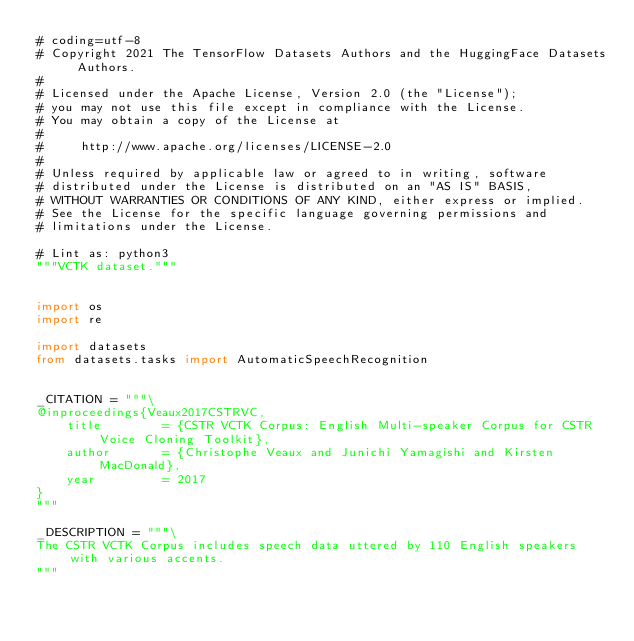<code> <loc_0><loc_0><loc_500><loc_500><_Python_># coding=utf-8
# Copyright 2021 The TensorFlow Datasets Authors and the HuggingFace Datasets Authors.
#
# Licensed under the Apache License, Version 2.0 (the "License");
# you may not use this file except in compliance with the License.
# You may obtain a copy of the License at
#
#     http://www.apache.org/licenses/LICENSE-2.0
#
# Unless required by applicable law or agreed to in writing, software
# distributed under the License is distributed on an "AS IS" BASIS,
# WITHOUT WARRANTIES OR CONDITIONS OF ANY KIND, either express or implied.
# See the License for the specific language governing permissions and
# limitations under the License.

# Lint as: python3
"""VCTK dataset."""


import os
import re

import datasets
from datasets.tasks import AutomaticSpeechRecognition


_CITATION = """\
@inproceedings{Veaux2017CSTRVC,
    title        = {CSTR VCTK Corpus: English Multi-speaker Corpus for CSTR Voice Cloning Toolkit},
    author       = {Christophe Veaux and Junichi Yamagishi and Kirsten MacDonald},
    year         = 2017
}
"""

_DESCRIPTION = """\
The CSTR VCTK Corpus includes speech data uttered by 110 English speakers with various accents.
"""
</code> 